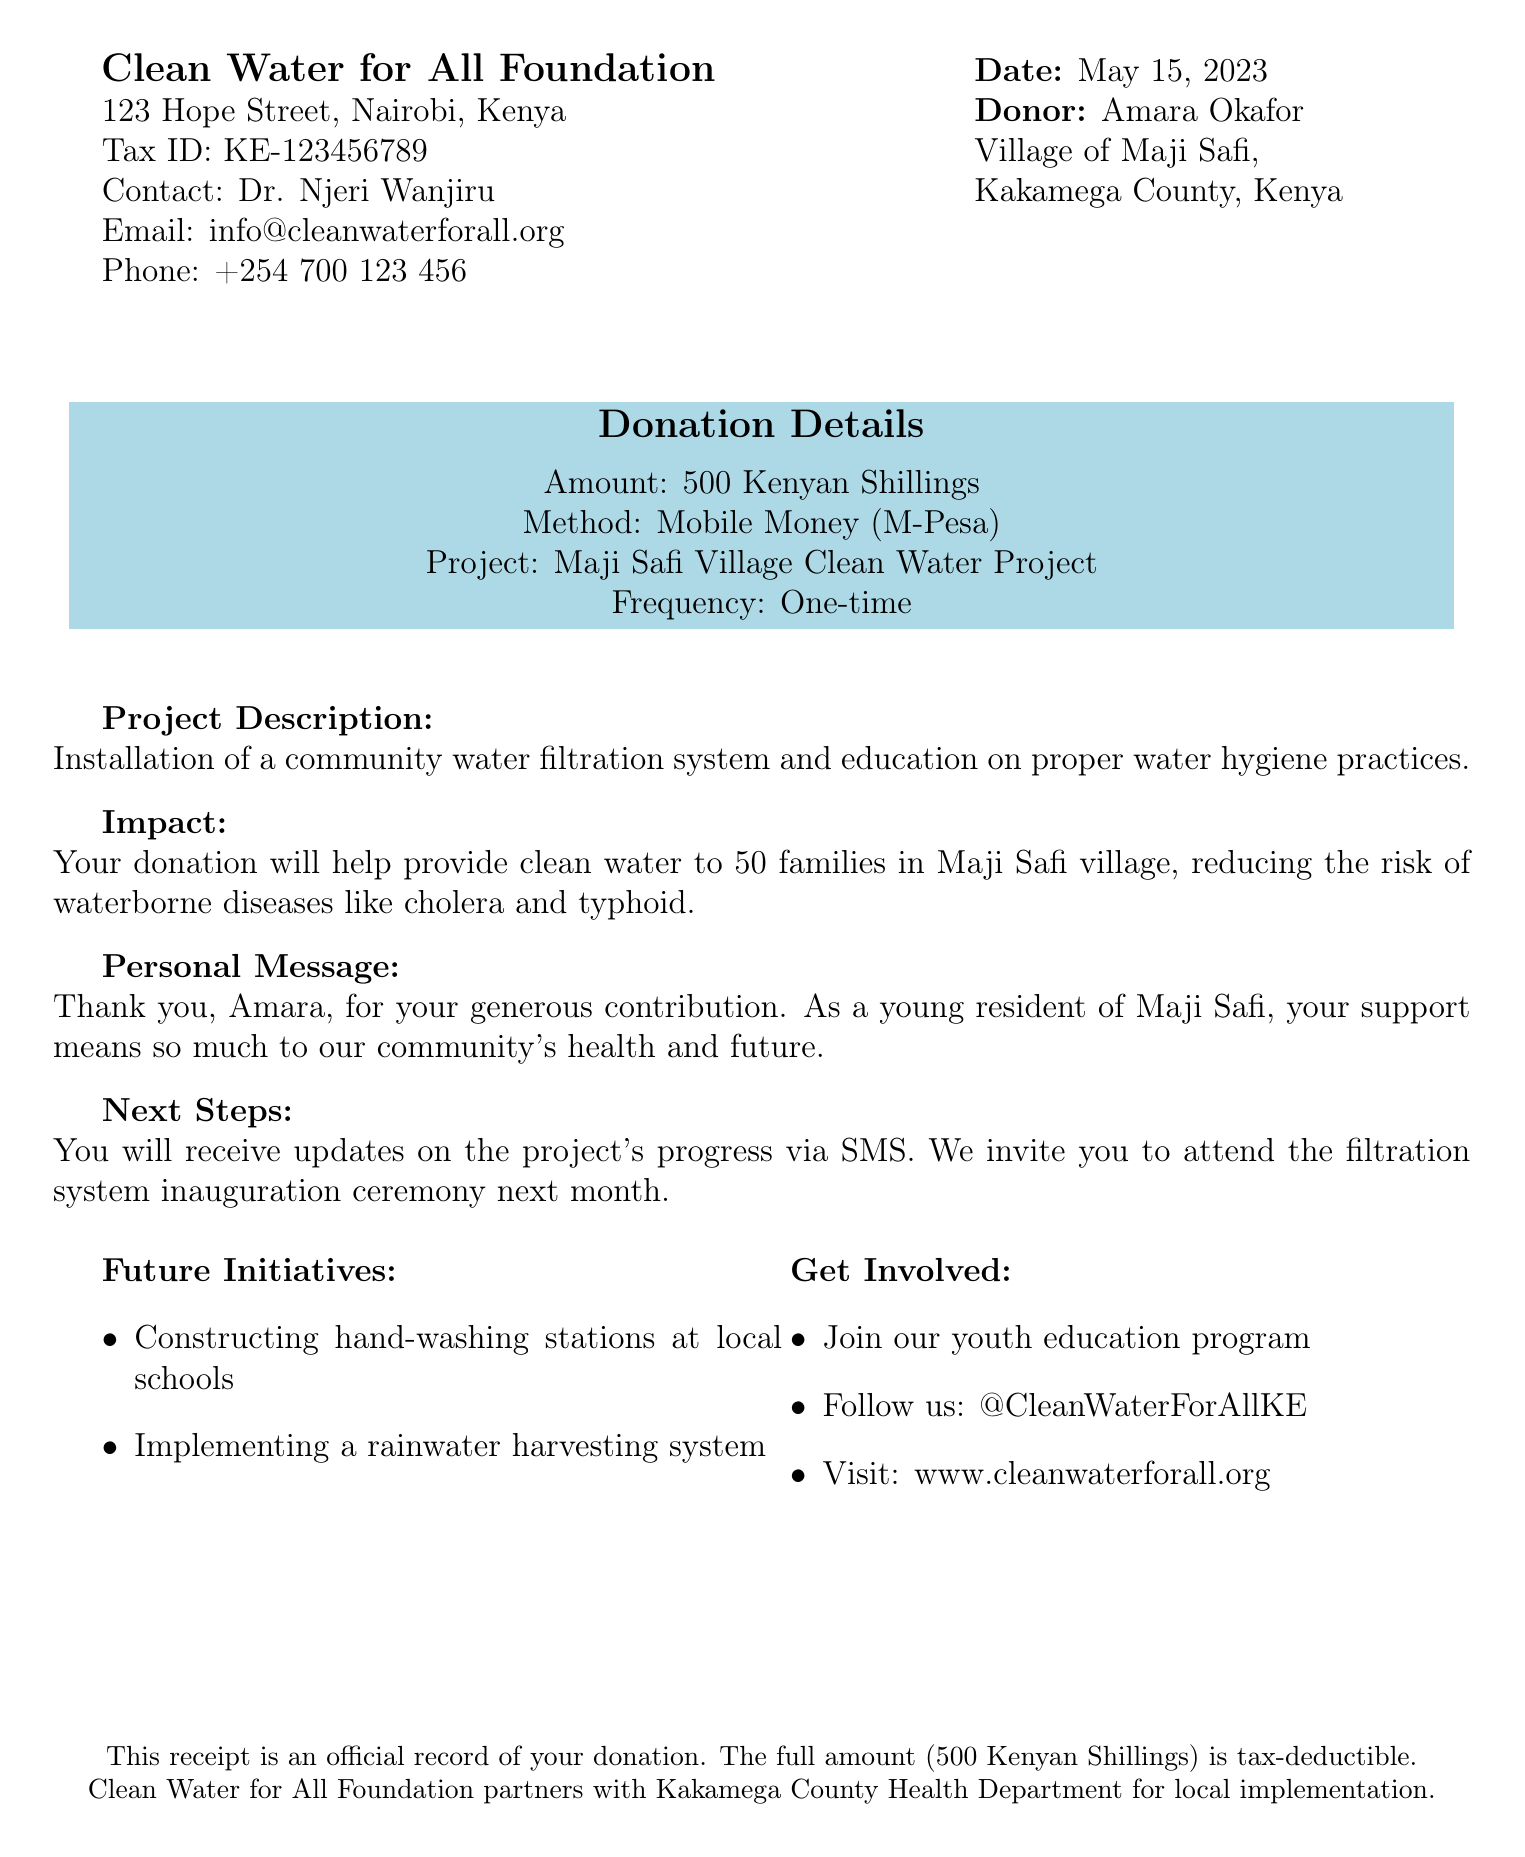What is the name of the organization? The organization that issued the donation receipt is listed at the top of the document.
Answer: Clean Water for All Foundation What was the donation amount? The document explicitly states the amount of the donation made by the donor.
Answer: 500 Kenyan Shillings Who is the contact person for the organization? The document provides the name of the individual to contact for more information related to the donation.
Answer: Dr. Njeri Wanjiru What method was used for the donation? The method of donation is clearly indicated in the details section of the receipt.
Answer: Mobile Money (M-Pesa) What is the project name related to this donation? The document includes the name of the specific project that the donation supports.
Answer: Maji Safi Village Clean Water Project How many families will benefit from the donation? The impact statement details how many families in the village will receive benefits from the project.
Answer: 50 families What is the tax ID of the organization? The tax ID is provided in the organization details section of the document.
Answer: KE-123456789 What was the date of the donation? The receipt includes the date when the donation was made.
Answer: May 15, 2023 What future initiative is mentioned in the document? The document lists upcoming projects that will be worked on as part of future efforts.
Answer: Constructing hand-washing stations at local schools 